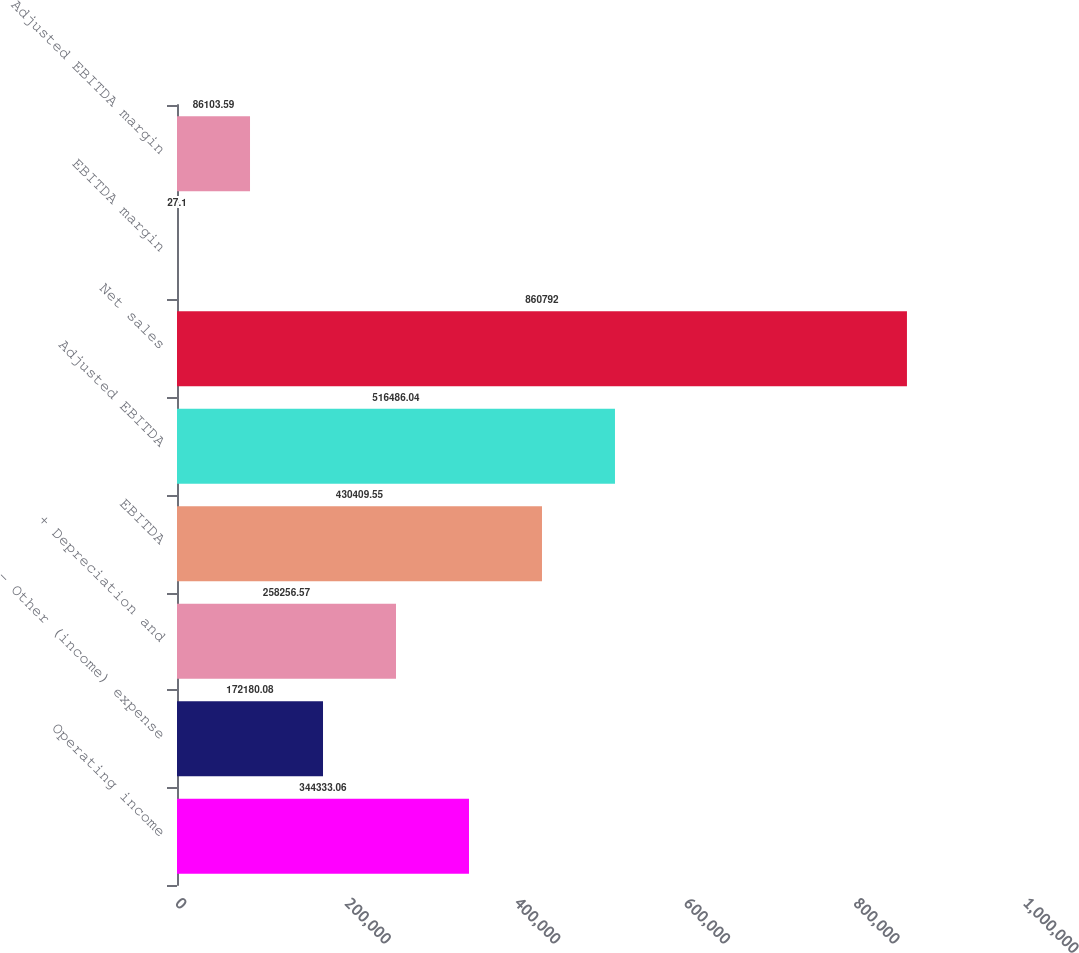Convert chart to OTSL. <chart><loc_0><loc_0><loc_500><loc_500><bar_chart><fcel>Operating income<fcel>- Other (income) expense<fcel>+ Depreciation and<fcel>EBITDA<fcel>Adjusted EBITDA<fcel>Net sales<fcel>EBITDA margin<fcel>Adjusted EBITDA margin<nl><fcel>344333<fcel>172180<fcel>258257<fcel>430410<fcel>516486<fcel>860792<fcel>27.1<fcel>86103.6<nl></chart> 